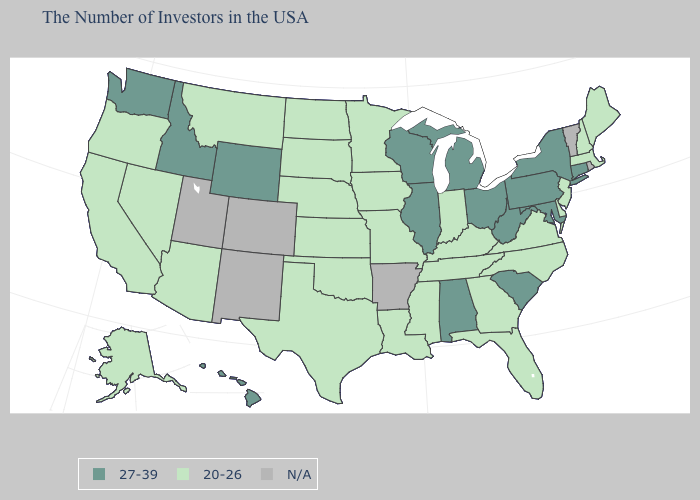Which states have the lowest value in the West?
Give a very brief answer. Montana, Arizona, Nevada, California, Oregon, Alaska. Does the map have missing data?
Write a very short answer. Yes. What is the value of Illinois?
Quick response, please. 27-39. What is the value of Minnesota?
Write a very short answer. 20-26. Name the states that have a value in the range 20-26?
Concise answer only. Maine, Massachusetts, New Hampshire, New Jersey, Delaware, Virginia, North Carolina, Florida, Georgia, Kentucky, Indiana, Tennessee, Mississippi, Louisiana, Missouri, Minnesota, Iowa, Kansas, Nebraska, Oklahoma, Texas, South Dakota, North Dakota, Montana, Arizona, Nevada, California, Oregon, Alaska. Among the states that border Washington , which have the lowest value?
Short answer required. Oregon. What is the value of Tennessee?
Give a very brief answer. 20-26. Name the states that have a value in the range N/A?
Keep it brief. Rhode Island, Vermont, Arkansas, Colorado, New Mexico, Utah. Name the states that have a value in the range 20-26?
Concise answer only. Maine, Massachusetts, New Hampshire, New Jersey, Delaware, Virginia, North Carolina, Florida, Georgia, Kentucky, Indiana, Tennessee, Mississippi, Louisiana, Missouri, Minnesota, Iowa, Kansas, Nebraska, Oklahoma, Texas, South Dakota, North Dakota, Montana, Arizona, Nevada, California, Oregon, Alaska. What is the highest value in states that border Massachusetts?
Give a very brief answer. 27-39. What is the value of New Mexico?
Keep it brief. N/A. Which states have the lowest value in the South?
Quick response, please. Delaware, Virginia, North Carolina, Florida, Georgia, Kentucky, Tennessee, Mississippi, Louisiana, Oklahoma, Texas. Which states have the lowest value in the West?
Short answer required. Montana, Arizona, Nevada, California, Oregon, Alaska. Name the states that have a value in the range 27-39?
Be succinct. Connecticut, New York, Maryland, Pennsylvania, South Carolina, West Virginia, Ohio, Michigan, Alabama, Wisconsin, Illinois, Wyoming, Idaho, Washington, Hawaii. Name the states that have a value in the range N/A?
Keep it brief. Rhode Island, Vermont, Arkansas, Colorado, New Mexico, Utah. 